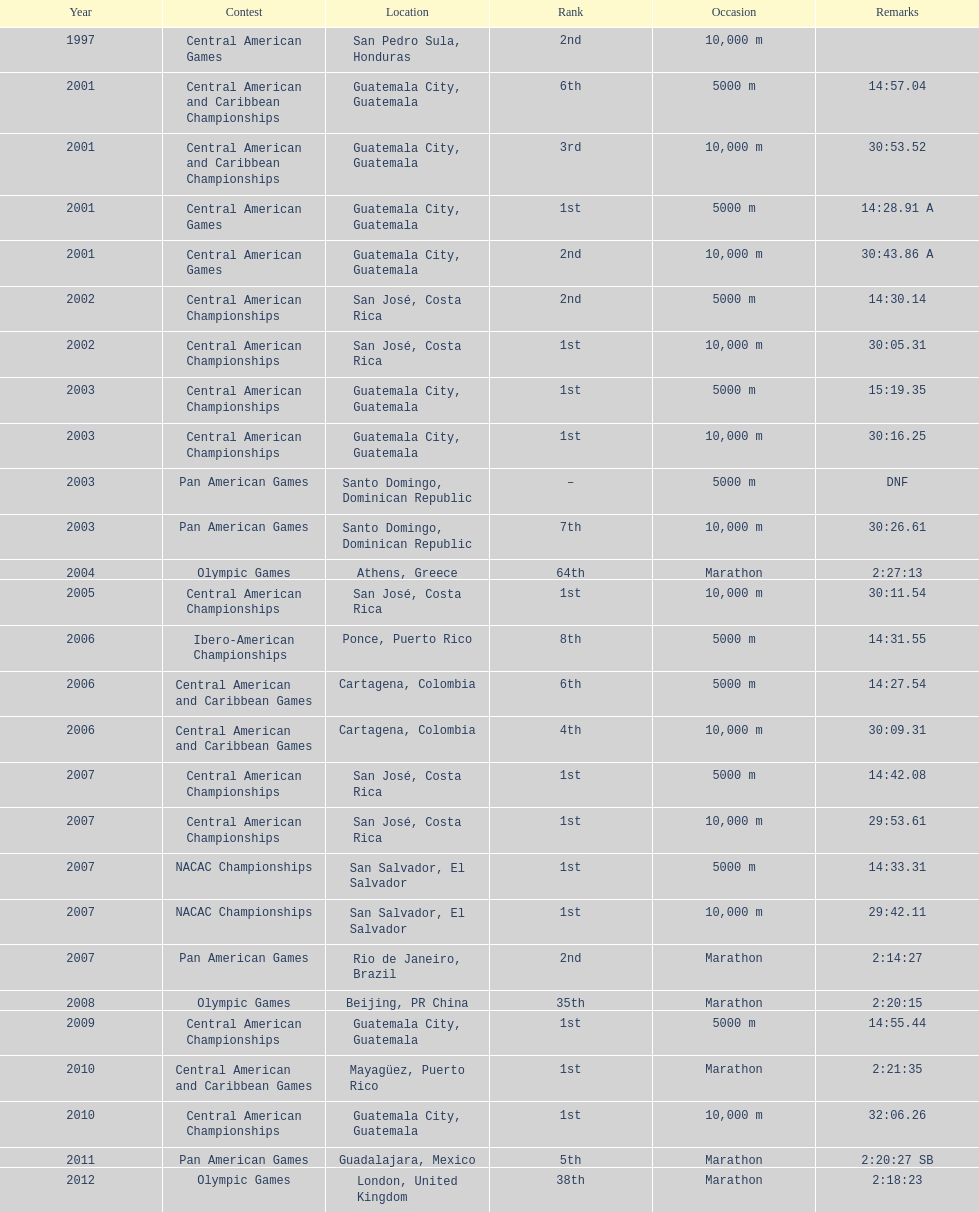The central american championships and what other competition occurred in 2010? Central American and Caribbean Games. 